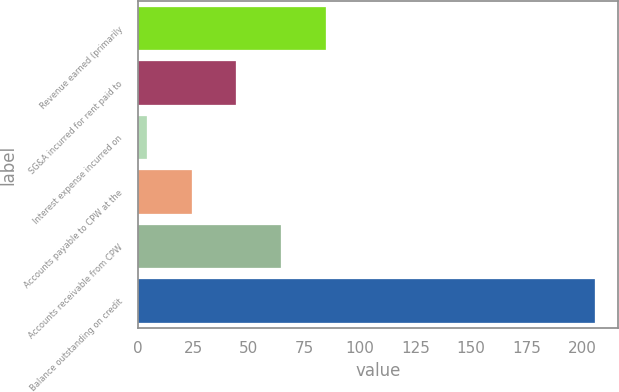Convert chart. <chart><loc_0><loc_0><loc_500><loc_500><bar_chart><fcel>Revenue earned (primarily<fcel>SG&A incurred for rent paid to<fcel>Interest expense incurred on<fcel>Accounts payable to CPW at the<fcel>Accounts receivable from CPW<fcel>Balance outstanding on credit<nl><fcel>84.8<fcel>44.4<fcel>4<fcel>24.2<fcel>64.6<fcel>206<nl></chart> 